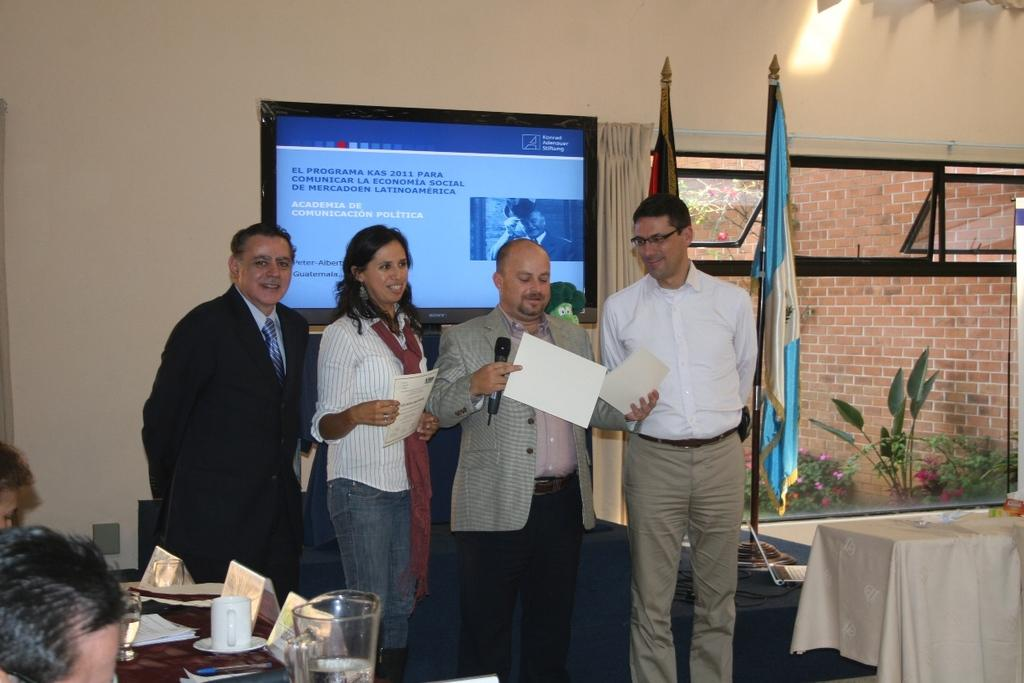What is the gender of the person standing in the image? There is a woman standing in the image. What type of clothing is the woman wearing? The woman is wearing a shirt and trousers. How many men are standing in the image? There are three men standing in the image. What can be seen behind the woman? There is an electronic display behind the woman. What is located on the right side of the image? There are two flags on the right side of the image. What type of science experiment is being conducted on the desk in the image? There is no desk present in the image, so it is not possible to determine if a science experiment is being conducted. 